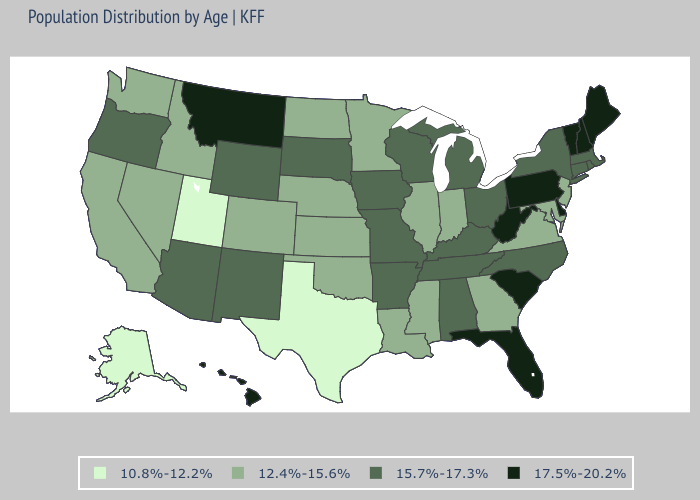What is the value of Colorado?
Keep it brief. 12.4%-15.6%. Does New Hampshire have the highest value in the Northeast?
Concise answer only. Yes. Does the map have missing data?
Short answer required. No. Name the states that have a value in the range 15.7%-17.3%?
Give a very brief answer. Alabama, Arizona, Arkansas, Connecticut, Iowa, Kentucky, Massachusetts, Michigan, Missouri, New Mexico, New York, North Carolina, Ohio, Oregon, Rhode Island, South Dakota, Tennessee, Wisconsin, Wyoming. What is the value of Indiana?
Answer briefly. 12.4%-15.6%. Does Alaska have the lowest value in the USA?
Quick response, please. Yes. What is the value of Ohio?
Be succinct. 15.7%-17.3%. What is the value of Rhode Island?
Keep it brief. 15.7%-17.3%. Does Vermont have the highest value in the USA?
Keep it brief. Yes. Name the states that have a value in the range 10.8%-12.2%?
Short answer required. Alaska, Texas, Utah. Does Kansas have the lowest value in the MidWest?
Short answer required. Yes. What is the value of Oklahoma?
Keep it brief. 12.4%-15.6%. Among the states that border Minnesota , does North Dakota have the highest value?
Concise answer only. No. What is the value of Missouri?
Quick response, please. 15.7%-17.3%. Which states have the highest value in the USA?
Keep it brief. Delaware, Florida, Hawaii, Maine, Montana, New Hampshire, Pennsylvania, South Carolina, Vermont, West Virginia. 